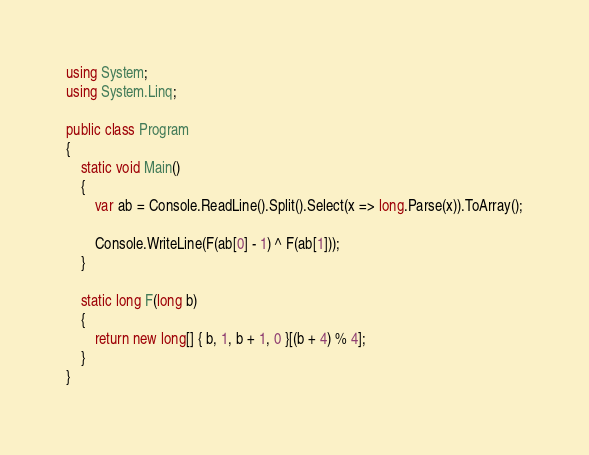<code> <loc_0><loc_0><loc_500><loc_500><_C#_>using System;
using System.Linq;

public class Program
{
    static void Main()
    {
        var ab = Console.ReadLine().Split().Select(x => long.Parse(x)).ToArray();

        Console.WriteLine(F(ab[0] - 1) ^ F(ab[1]));
    }

    static long F(long b)
    {
        return new long[] { b, 1, b + 1, 0 }[(b + 4) % 4];
    }
}</code> 